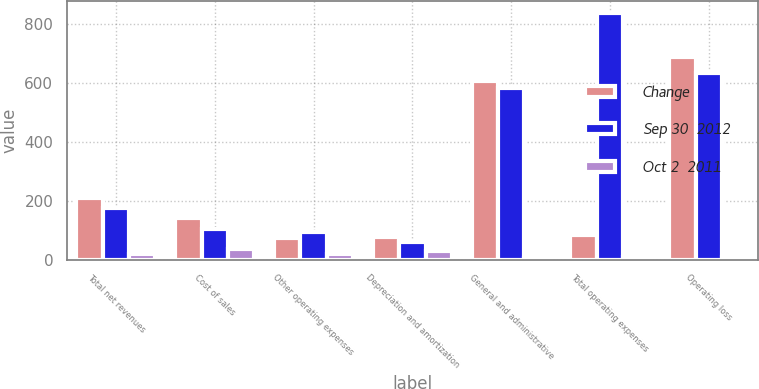Convert chart. <chart><loc_0><loc_0><loc_500><loc_500><stacked_bar_chart><ecel><fcel>Total net revenues<fcel>Cost of sales<fcel>Other operating expenses<fcel>Depreciation and amortization<fcel>General and administrative<fcel>Total operating expenses<fcel>Operating loss<nl><fcel>Change<fcel>208.6<fcel>140.1<fcel>74.4<fcel>76.4<fcel>607.8<fcel>84.7<fcel>689.4<nl><fcel>Sep 30  2012<fcel>175.8<fcel>103<fcel>93<fcel>58.6<fcel>584<fcel>838.6<fcel>635<nl><fcel>Oct 2  2011<fcel>18.7<fcel>36<fcel>20<fcel>30.4<fcel>4.1<fcel>7.2<fcel>8.6<nl></chart> 